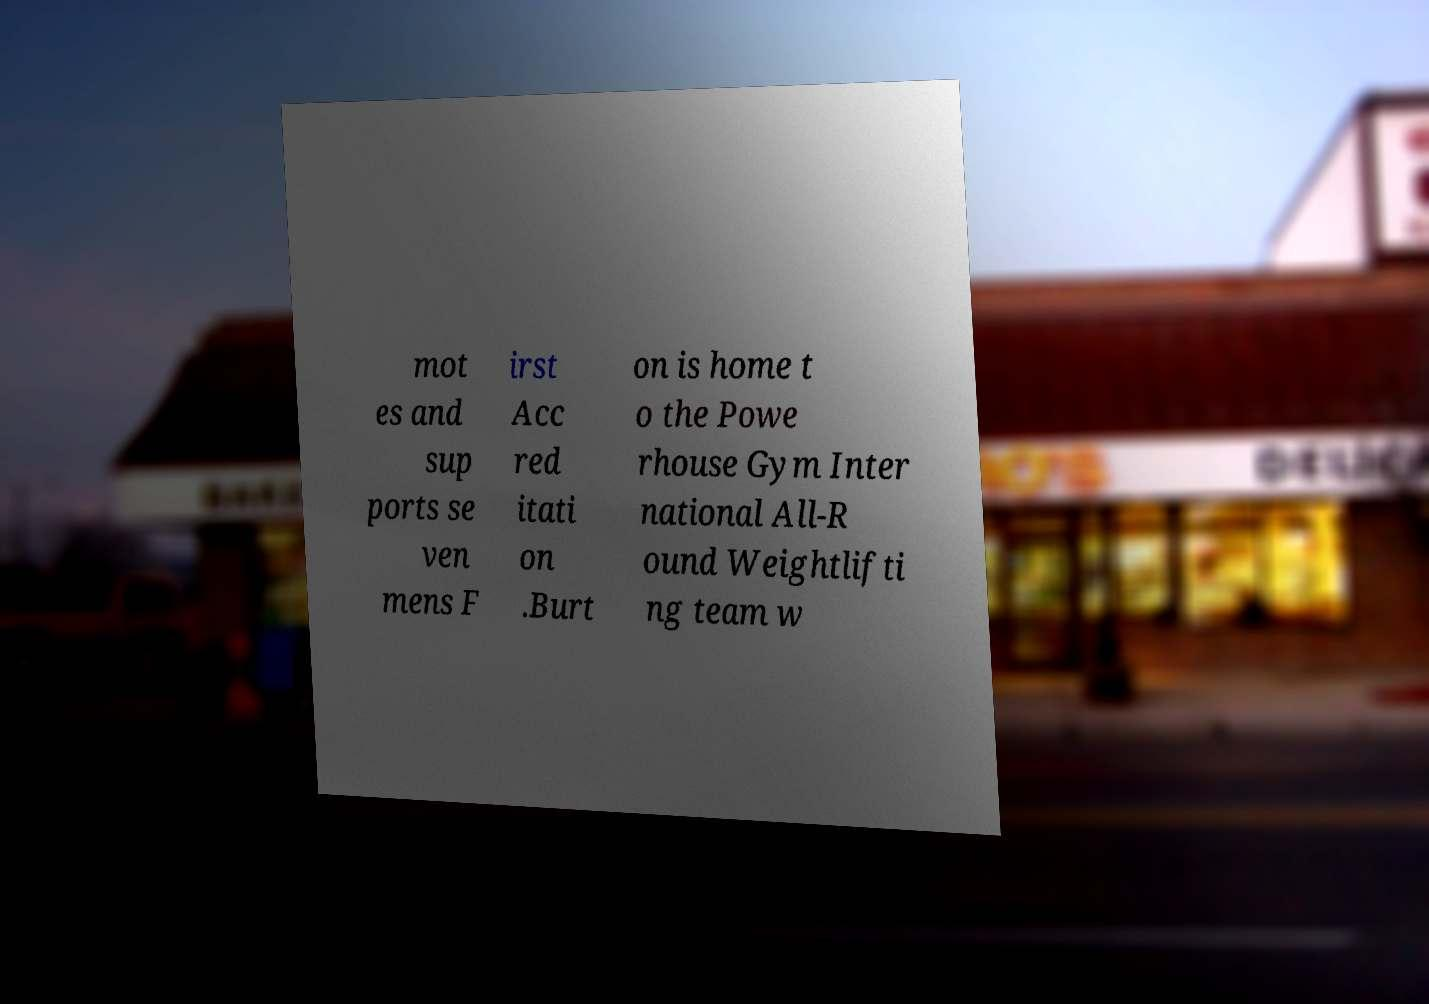There's text embedded in this image that I need extracted. Can you transcribe it verbatim? mot es and sup ports se ven mens F irst Acc red itati on .Burt on is home t o the Powe rhouse Gym Inter national All-R ound Weightlifti ng team w 